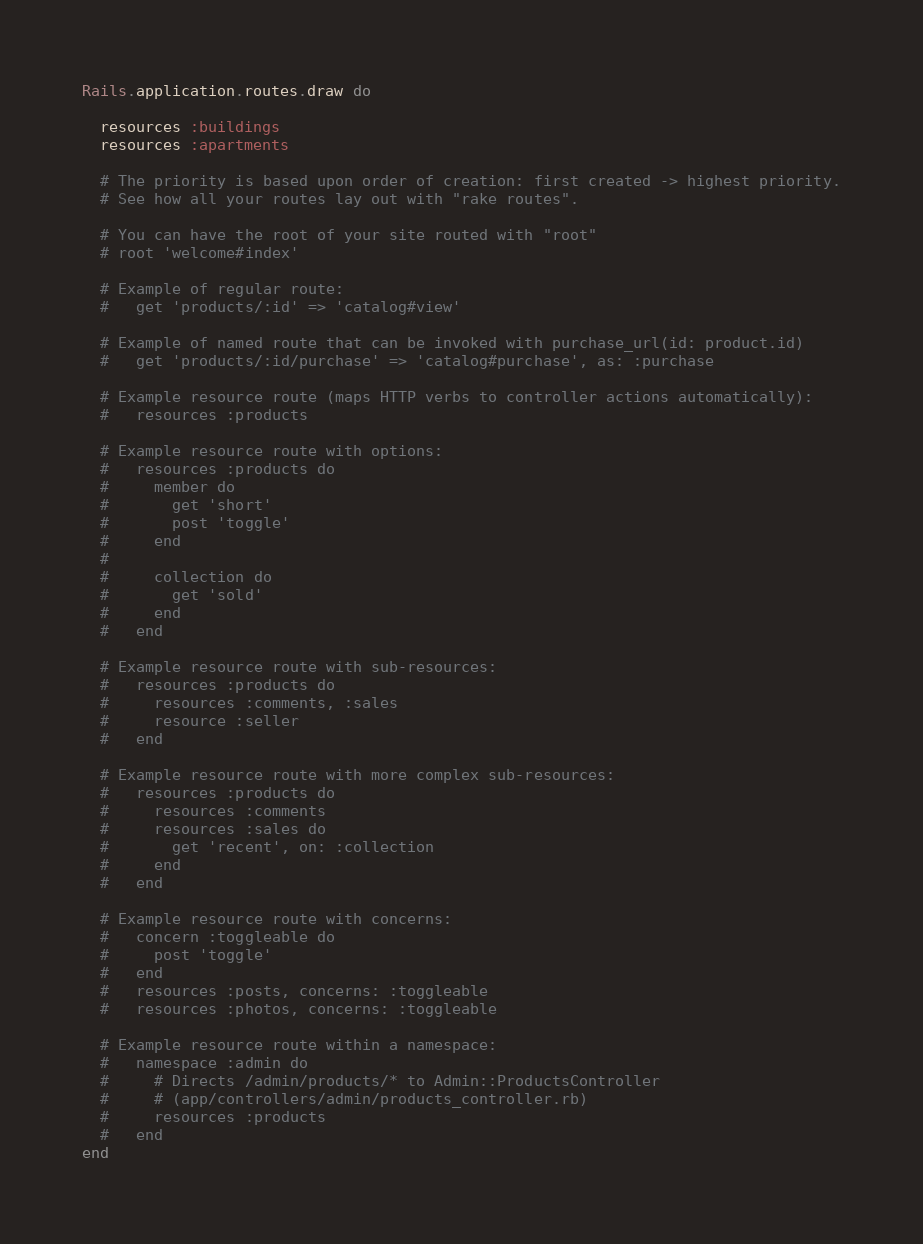Convert code to text. <code><loc_0><loc_0><loc_500><loc_500><_Ruby_>Rails.application.routes.draw do

  resources :buildings
  resources :apartments

  # The priority is based upon order of creation: first created -> highest priority.
  # See how all your routes lay out with "rake routes".

  # You can have the root of your site routed with "root"
  # root 'welcome#index'

  # Example of regular route:
  #   get 'products/:id' => 'catalog#view'

  # Example of named route that can be invoked with purchase_url(id: product.id)
  #   get 'products/:id/purchase' => 'catalog#purchase', as: :purchase

  # Example resource route (maps HTTP verbs to controller actions automatically):
  #   resources :products

  # Example resource route with options:
  #   resources :products do
  #     member do
  #       get 'short'
  #       post 'toggle'
  #     end
  #
  #     collection do
  #       get 'sold'
  #     end
  #   end

  # Example resource route with sub-resources:
  #   resources :products do
  #     resources :comments, :sales
  #     resource :seller
  #   end

  # Example resource route with more complex sub-resources:
  #   resources :products do
  #     resources :comments
  #     resources :sales do
  #       get 'recent', on: :collection
  #     end
  #   end

  # Example resource route with concerns:
  #   concern :toggleable do
  #     post 'toggle'
  #   end
  #   resources :posts, concerns: :toggleable
  #   resources :photos, concerns: :toggleable

  # Example resource route within a namespace:
  #   namespace :admin do
  #     # Directs /admin/products/* to Admin::ProductsController
  #     # (app/controllers/admin/products_controller.rb)
  #     resources :products
  #   end
end
</code> 